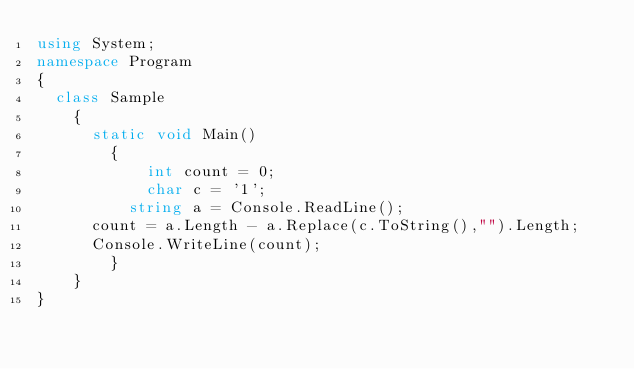<code> <loc_0><loc_0><loc_500><loc_500><_C#_>using System;
namespace Program
{
	class Sample
    {
    	static void Main()
        {
          	int count = 0;
          	char c = '1';
        	string a = Console.ReadLine();
			count = a.Length - a.Replace(c.ToString(),"").Length;
			Console.WriteLine(count);
        }
    }
}</code> 